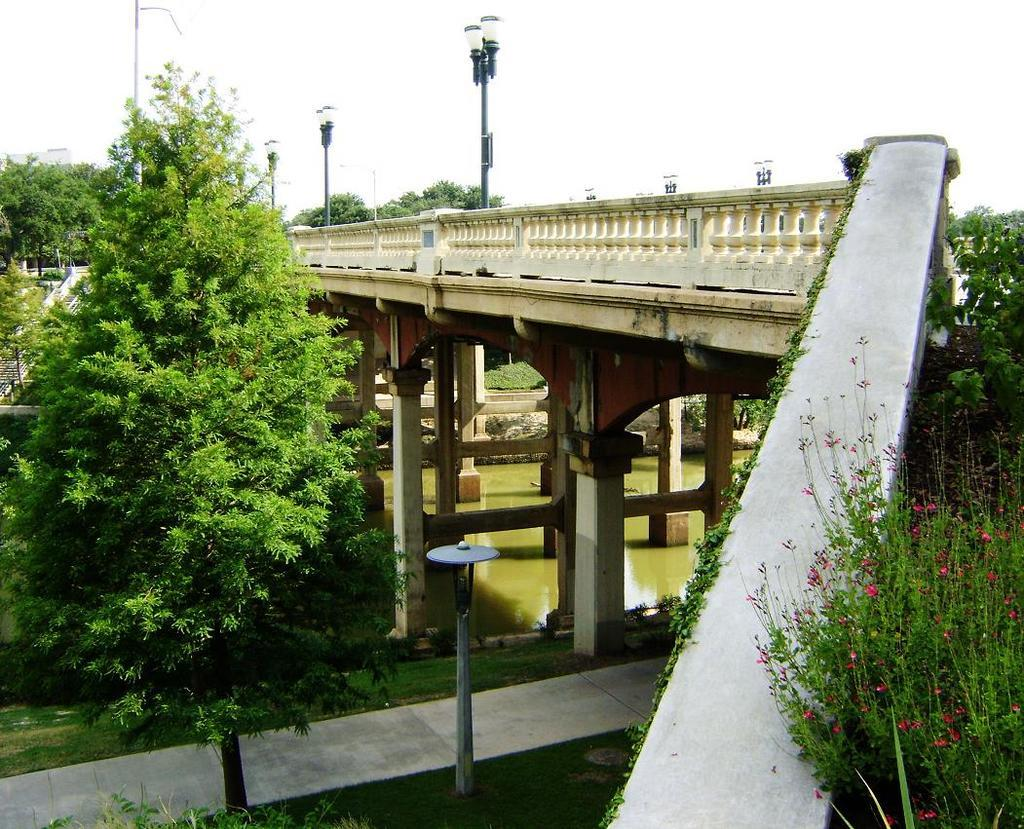What is the main structure in the image? There is a bridge in the image. What is the bridge positioned over? The bridge is over a river. What type of infrastructure can be seen in the image? There are street poles and street lights in the image. What type of vegetation is present in the image? There are trees in the image. What type of architectural feature is present in the image? There is a staircase in the image. What type of material is visible in the image? There are stones in the image. What part of the natural environment is visible in the image? The ground and the sky are visible in the image. What type of sock is hanging on the street pole in the image? There is no sock present in the image; it is not mentioned in the provided facts. 